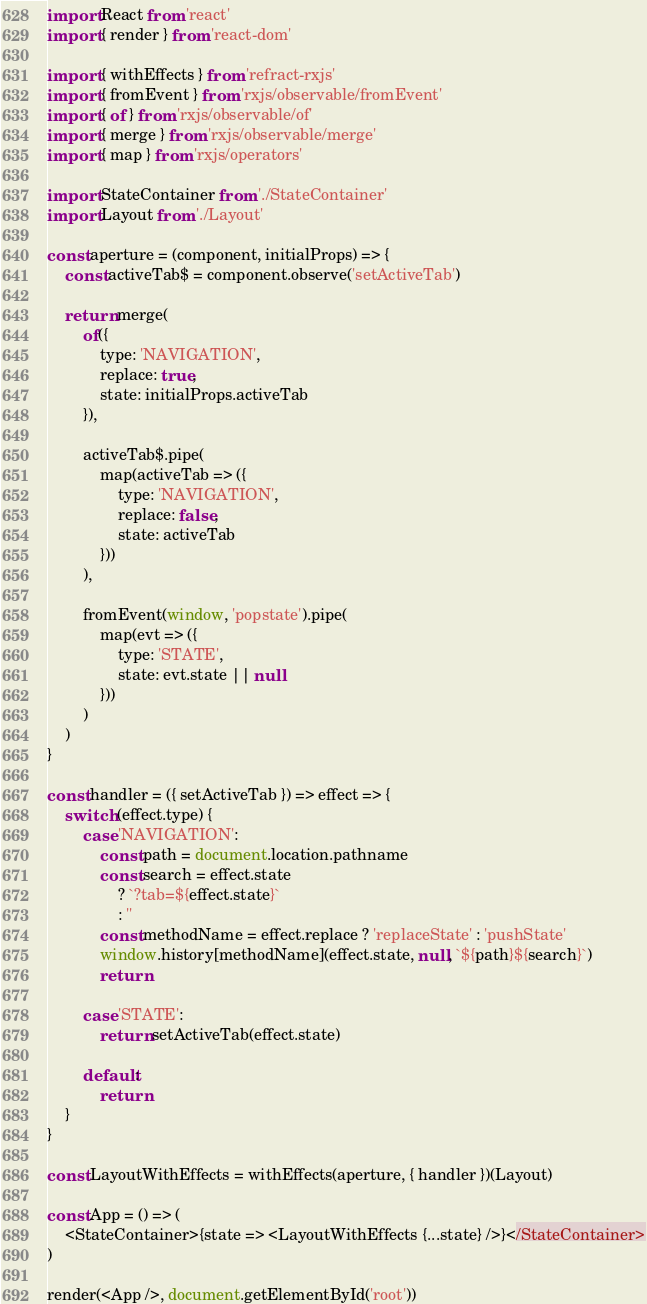Convert code to text. <code><loc_0><loc_0><loc_500><loc_500><_JavaScript_>import React from 'react'
import { render } from 'react-dom'

import { withEffects } from 'refract-rxjs'
import { fromEvent } from 'rxjs/observable/fromEvent'
import { of } from 'rxjs/observable/of'
import { merge } from 'rxjs/observable/merge'
import { map } from 'rxjs/operators'

import StateContainer from './StateContainer'
import Layout from './Layout'

const aperture = (component, initialProps) => {
    const activeTab$ = component.observe('setActiveTab')

    return merge(
        of({
            type: 'NAVIGATION',
            replace: true,
            state: initialProps.activeTab
        }),

        activeTab$.pipe(
            map(activeTab => ({
                type: 'NAVIGATION',
                replace: false,
                state: activeTab
            }))
        ),

        fromEvent(window, 'popstate').pipe(
            map(evt => ({
                type: 'STATE',
                state: evt.state || null
            }))
        )
    )
}

const handler = ({ setActiveTab }) => effect => {
    switch (effect.type) {
        case 'NAVIGATION':
            const path = document.location.pathname
            const search = effect.state
                ? `?tab=${effect.state}`
                : ''
            const methodName = effect.replace ? 'replaceState' : 'pushState'
            window.history[methodName](effect.state, null, `${path}${search}`)
            return

        case 'STATE':
            return setActiveTab(effect.state)

        default:
            return
    }
}

const LayoutWithEffects = withEffects(aperture, { handler })(Layout)

const App = () => (
    <StateContainer>{state => <LayoutWithEffects {...state} />}</StateContainer>
)

render(<App />, document.getElementById('root'))
</code> 